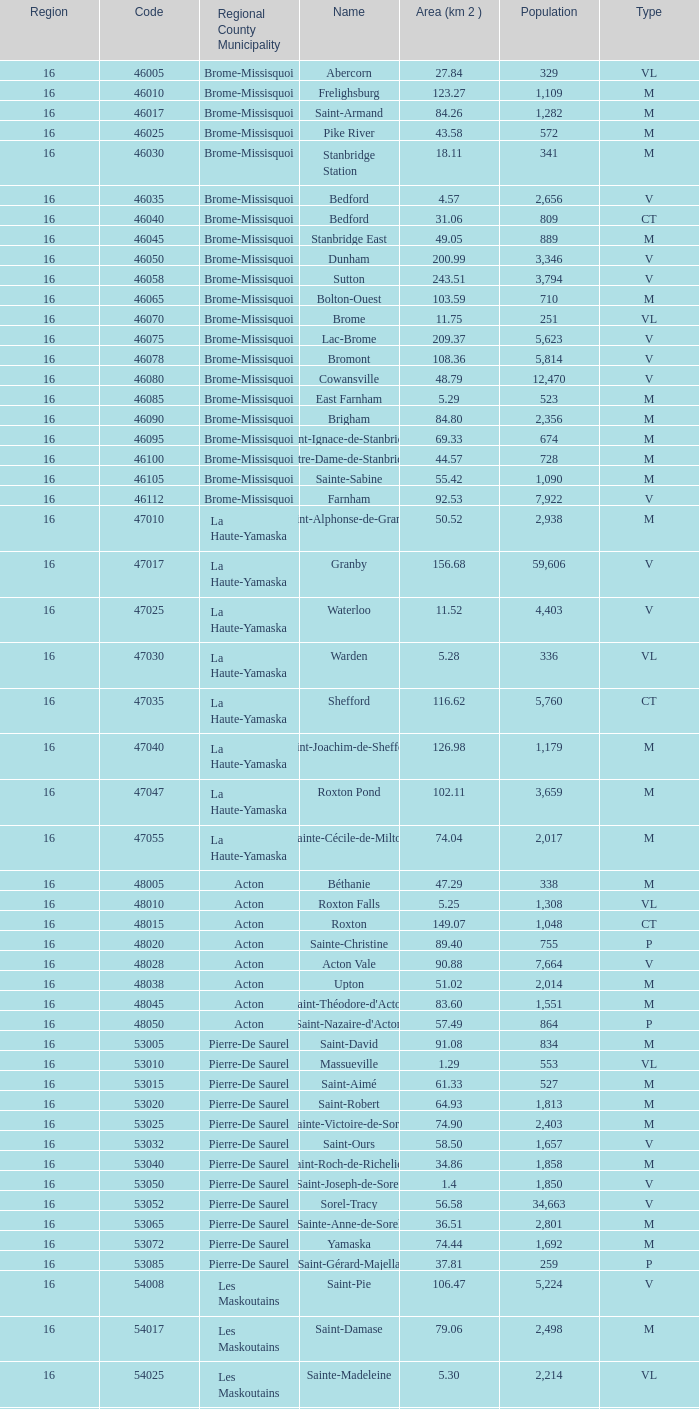Saint-Blaise-Sur-Richelieu is smaller than 68.42 km^2, what is the population of this type M municipality? None. 